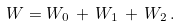Convert formula to latex. <formula><loc_0><loc_0><loc_500><loc_500>W = W _ { 0 } \, + \, W _ { 1 } \, + \, W _ { 2 } \, .</formula> 